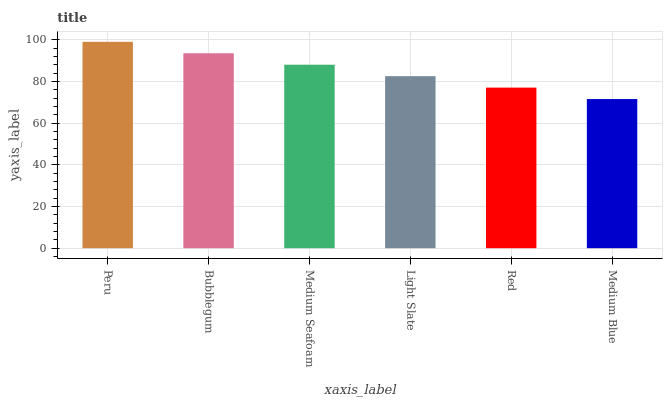Is Medium Blue the minimum?
Answer yes or no. Yes. Is Peru the maximum?
Answer yes or no. Yes. Is Bubblegum the minimum?
Answer yes or no. No. Is Bubblegum the maximum?
Answer yes or no. No. Is Peru greater than Bubblegum?
Answer yes or no. Yes. Is Bubblegum less than Peru?
Answer yes or no. Yes. Is Bubblegum greater than Peru?
Answer yes or no. No. Is Peru less than Bubblegum?
Answer yes or no. No. Is Medium Seafoam the high median?
Answer yes or no. Yes. Is Light Slate the low median?
Answer yes or no. Yes. Is Medium Blue the high median?
Answer yes or no. No. Is Medium Blue the low median?
Answer yes or no. No. 